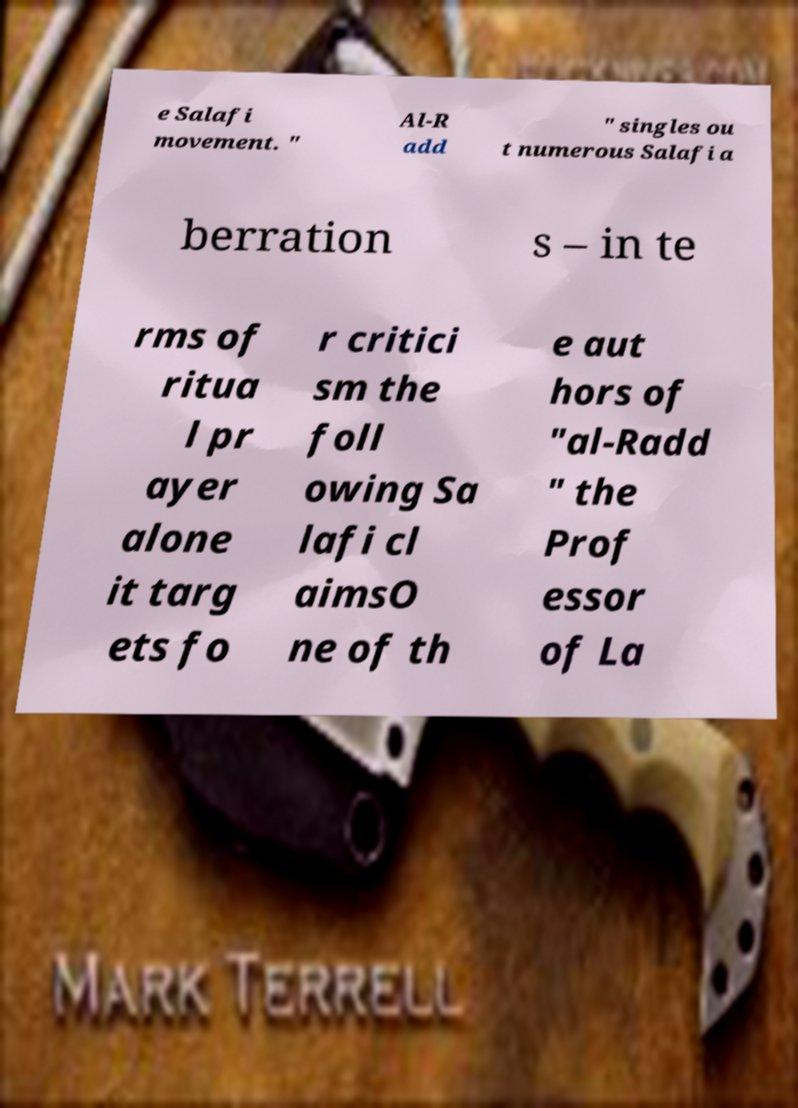Could you extract and type out the text from this image? e Salafi movement. " Al-R add " singles ou t numerous Salafi a berration s – in te rms of ritua l pr ayer alone it targ ets fo r critici sm the foll owing Sa lafi cl aimsO ne of th e aut hors of "al-Radd " the Prof essor of La 